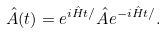<formula> <loc_0><loc_0><loc_500><loc_500>\hat { A } ( t ) = e ^ { i \hat { H } t / } \hat { A } e ^ { - i \hat { H } t / } .</formula> 